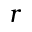<formula> <loc_0><loc_0><loc_500><loc_500>r</formula> 